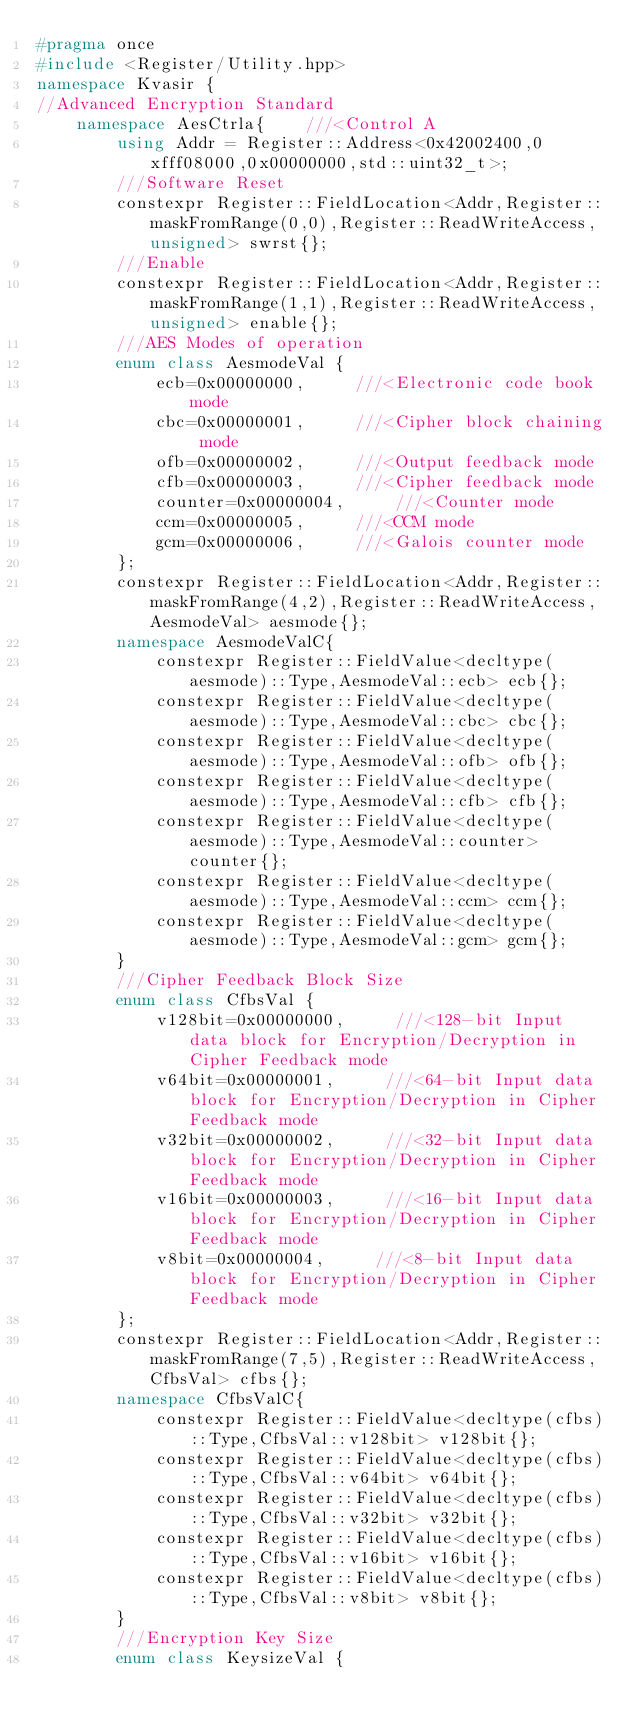Convert code to text. <code><loc_0><loc_0><loc_500><loc_500><_C++_>#pragma once 
#include <Register/Utility.hpp>
namespace Kvasir {
//Advanced Encryption Standard
    namespace AesCtrla{    ///<Control A
        using Addr = Register::Address<0x42002400,0xfff08000,0x00000000,std::uint32_t>;
        ///Software Reset
        constexpr Register::FieldLocation<Addr,Register::maskFromRange(0,0),Register::ReadWriteAccess,unsigned> swrst{}; 
        ///Enable
        constexpr Register::FieldLocation<Addr,Register::maskFromRange(1,1),Register::ReadWriteAccess,unsigned> enable{}; 
        ///AES Modes of operation
        enum class AesmodeVal {
            ecb=0x00000000,     ///<Electronic code book mode
            cbc=0x00000001,     ///<Cipher block chaining mode
            ofb=0x00000002,     ///<Output feedback mode
            cfb=0x00000003,     ///<Cipher feedback mode
            counter=0x00000004,     ///<Counter mode
            ccm=0x00000005,     ///<CCM mode
            gcm=0x00000006,     ///<Galois counter mode
        };
        constexpr Register::FieldLocation<Addr,Register::maskFromRange(4,2),Register::ReadWriteAccess,AesmodeVal> aesmode{}; 
        namespace AesmodeValC{
            constexpr Register::FieldValue<decltype(aesmode)::Type,AesmodeVal::ecb> ecb{};
            constexpr Register::FieldValue<decltype(aesmode)::Type,AesmodeVal::cbc> cbc{};
            constexpr Register::FieldValue<decltype(aesmode)::Type,AesmodeVal::ofb> ofb{};
            constexpr Register::FieldValue<decltype(aesmode)::Type,AesmodeVal::cfb> cfb{};
            constexpr Register::FieldValue<decltype(aesmode)::Type,AesmodeVal::counter> counter{};
            constexpr Register::FieldValue<decltype(aesmode)::Type,AesmodeVal::ccm> ccm{};
            constexpr Register::FieldValue<decltype(aesmode)::Type,AesmodeVal::gcm> gcm{};
        }
        ///Cipher Feedback Block Size
        enum class CfbsVal {
            v128bit=0x00000000,     ///<128-bit Input data block for Encryption/Decryption in Cipher Feedback mode
            v64bit=0x00000001,     ///<64-bit Input data block for Encryption/Decryption in Cipher Feedback mode
            v32bit=0x00000002,     ///<32-bit Input data block for Encryption/Decryption in Cipher Feedback mode
            v16bit=0x00000003,     ///<16-bit Input data block for Encryption/Decryption in Cipher Feedback mode
            v8bit=0x00000004,     ///<8-bit Input data block for Encryption/Decryption in Cipher Feedback mode
        };
        constexpr Register::FieldLocation<Addr,Register::maskFromRange(7,5),Register::ReadWriteAccess,CfbsVal> cfbs{}; 
        namespace CfbsValC{
            constexpr Register::FieldValue<decltype(cfbs)::Type,CfbsVal::v128bit> v128bit{};
            constexpr Register::FieldValue<decltype(cfbs)::Type,CfbsVal::v64bit> v64bit{};
            constexpr Register::FieldValue<decltype(cfbs)::Type,CfbsVal::v32bit> v32bit{};
            constexpr Register::FieldValue<decltype(cfbs)::Type,CfbsVal::v16bit> v16bit{};
            constexpr Register::FieldValue<decltype(cfbs)::Type,CfbsVal::v8bit> v8bit{};
        }
        ///Encryption Key Size
        enum class KeysizeVal {</code> 